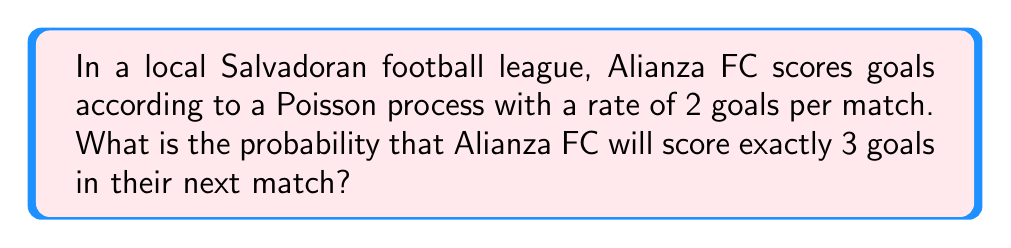What is the answer to this math problem? To solve this problem, we'll use the Poisson distribution formula, which is appropriate for modeling the number of events (in this case, goals) occurring in a fixed interval (one match) when the events happen at a known constant rate.

The Poisson probability mass function is given by:

$$P(X = k) = \frac{e^{-\lambda} \lambda^k}{k!}$$

Where:
- $\lambda$ is the average rate of events (goals per match)
- $k$ is the number of events (goals) we're interested in
- $e$ is Euler's number (approximately 2.71828)

Given:
- $\lambda = 2$ goals per match
- $k = 3$ goals

Let's plug these values into the formula:

$$P(X = 3) = \frac{e^{-2} 2^3}{3!}$$

Step 1: Calculate $2^3 = 8$

Step 2: Calculate $3! = 3 \times 2 \times 1 = 6$

Step 3: Calculate $e^{-2} \approx 0.1353$

Step 4: Put it all together:

$$P(X = 3) = \frac{0.1353 \times 8}{6} \approx 0.1804$$

Step 5: Convert to a percentage:

$0.1804 \times 100\% = 18.04\%$

Therefore, the probability that Alianza FC will score exactly 3 goals in their next match is approximately 18.04%.
Answer: 18.04% 